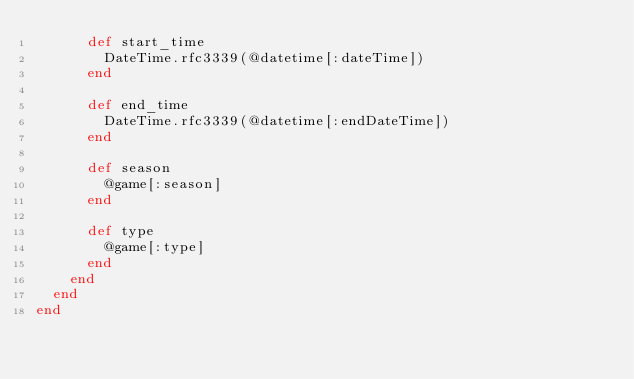<code> <loc_0><loc_0><loc_500><loc_500><_Ruby_>      def start_time
        DateTime.rfc3339(@datetime[:dateTime])
      end

      def end_time
        DateTime.rfc3339(@datetime[:endDateTime])
      end

      def season
        @game[:season]
      end

      def type
        @game[:type]
      end
    end
  end
end</code> 